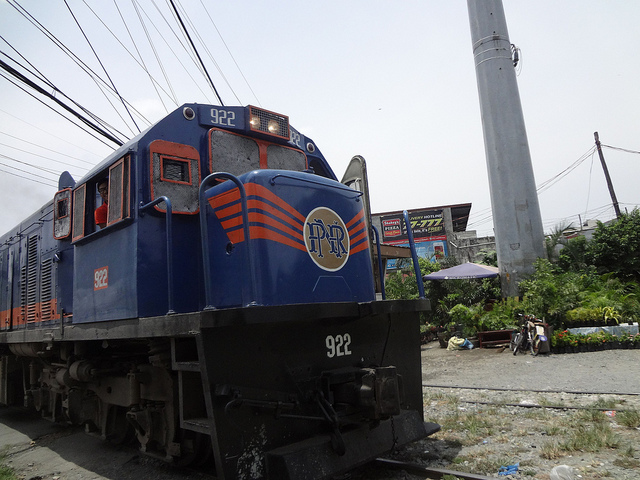Please identify all text content in this image. 922 922 PNR 922 7-777 